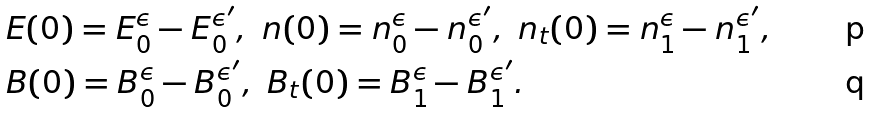<formula> <loc_0><loc_0><loc_500><loc_500>& E ( 0 ) = E ^ { \epsilon } _ { 0 } - E ^ { \epsilon ^ { \prime } } _ { 0 } , \ n ( 0 ) = n ^ { \epsilon } _ { 0 } - n ^ { \epsilon ^ { \prime } } _ { 0 } , \ n _ { t } ( 0 ) = n ^ { \epsilon } _ { 1 } - n ^ { \epsilon ^ { \prime } } _ { 1 } , \\ & B ( 0 ) = B ^ { \epsilon } _ { 0 } - B ^ { \epsilon ^ { \prime } } _ { 0 } , \ B _ { t } ( 0 ) = B ^ { \epsilon } _ { 1 } - B ^ { \epsilon ^ { \prime } } _ { 1 } .</formula> 